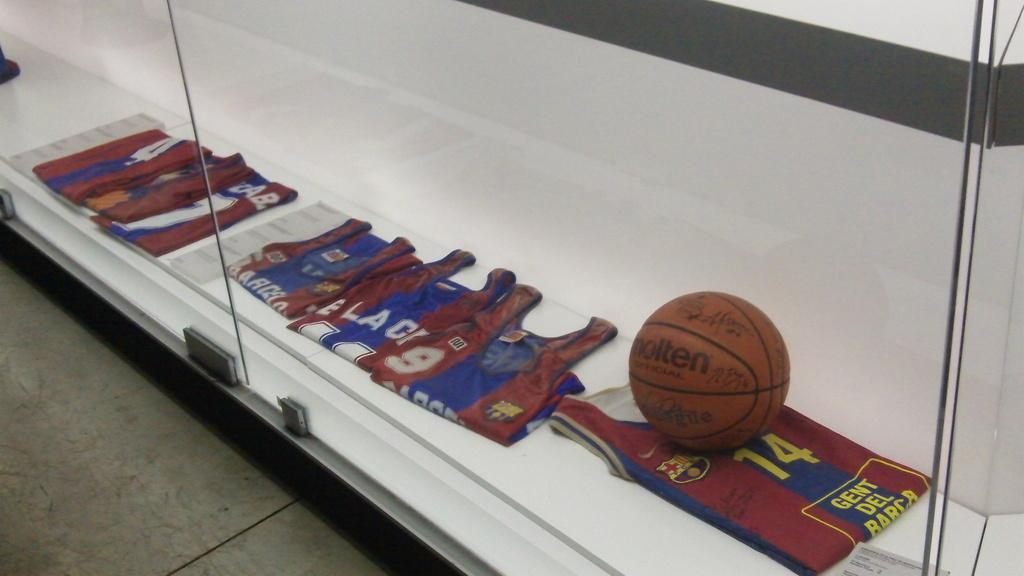<image>
Present a compact description of the photo's key features. A Molten basketball and several jerseys are behind a glass display. 